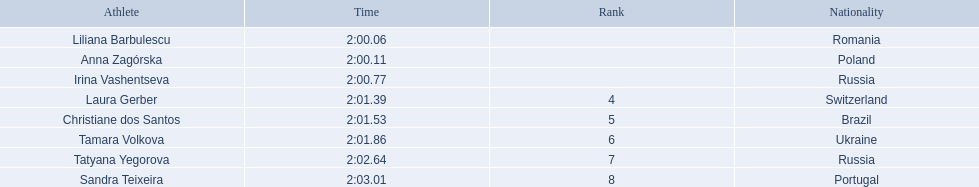What are the names of the competitors? Liliana Barbulescu, Anna Zagórska, Irina Vashentseva, Laura Gerber, Christiane dos Santos, Tamara Volkova, Tatyana Yegorova, Sandra Teixeira. Which finalist finished the fastest? Liliana Barbulescu. 